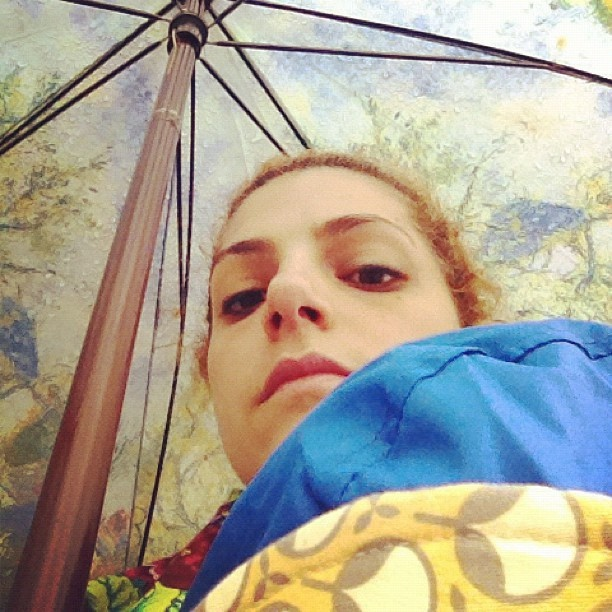Describe the objects in this image and their specific colors. I can see umbrella in beige, ivory, darkgray, and tan tones and people in beige, khaki, lightblue, tan, and blue tones in this image. 